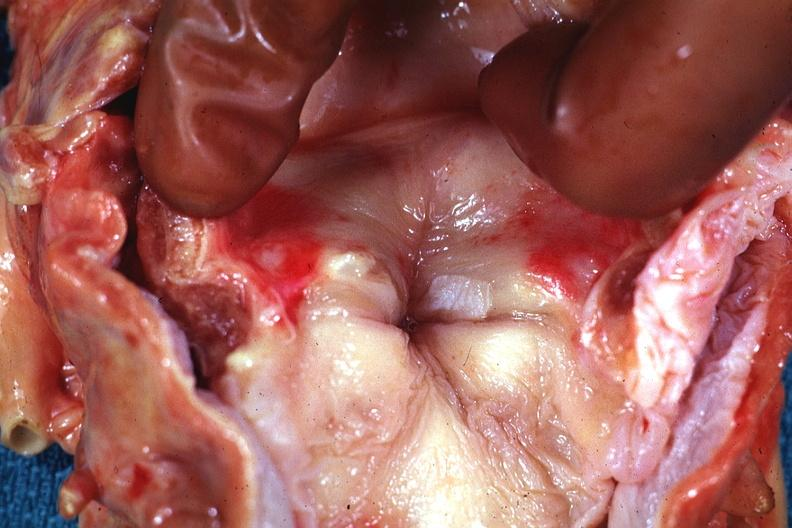s oral present?
Answer the question using a single word or phrase. Yes 